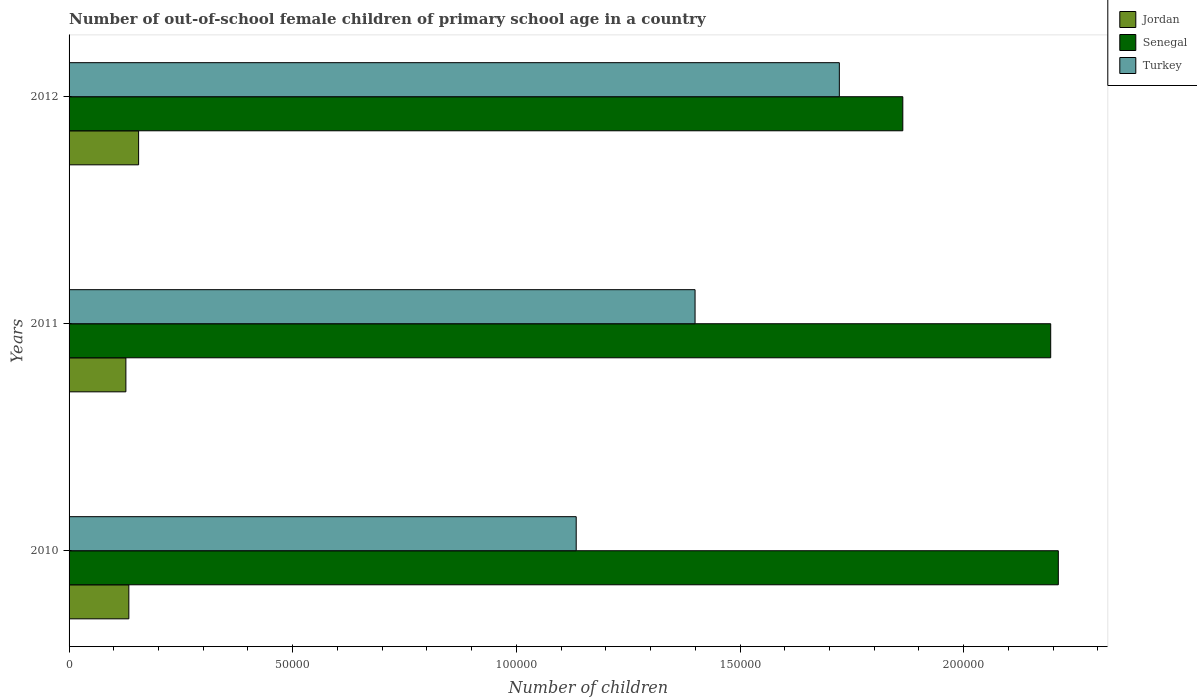How many different coloured bars are there?
Give a very brief answer. 3. Are the number of bars on each tick of the Y-axis equal?
Provide a short and direct response. Yes. How many bars are there on the 2nd tick from the top?
Your response must be concise. 3. How many bars are there on the 3rd tick from the bottom?
Ensure brevity in your answer.  3. What is the number of out-of-school female children in Jordan in 2010?
Keep it short and to the point. 1.34e+04. Across all years, what is the maximum number of out-of-school female children in Jordan?
Your response must be concise. 1.55e+04. Across all years, what is the minimum number of out-of-school female children in Jordan?
Give a very brief answer. 1.27e+04. In which year was the number of out-of-school female children in Turkey minimum?
Your response must be concise. 2010. What is the total number of out-of-school female children in Senegal in the graph?
Ensure brevity in your answer.  6.27e+05. What is the difference between the number of out-of-school female children in Senegal in 2010 and that in 2012?
Provide a short and direct response. 3.48e+04. What is the difference between the number of out-of-school female children in Senegal in 2010 and the number of out-of-school female children in Jordan in 2012?
Your answer should be compact. 2.06e+05. What is the average number of out-of-school female children in Turkey per year?
Make the answer very short. 1.42e+05. In the year 2012, what is the difference between the number of out-of-school female children in Senegal and number of out-of-school female children in Jordan?
Provide a short and direct response. 1.71e+05. In how many years, is the number of out-of-school female children in Jordan greater than 200000 ?
Provide a short and direct response. 0. What is the ratio of the number of out-of-school female children in Jordan in 2010 to that in 2012?
Ensure brevity in your answer.  0.86. Is the difference between the number of out-of-school female children in Senegal in 2010 and 2012 greater than the difference between the number of out-of-school female children in Jordan in 2010 and 2012?
Ensure brevity in your answer.  Yes. What is the difference between the highest and the second highest number of out-of-school female children in Senegal?
Provide a short and direct response. 1704. What is the difference between the highest and the lowest number of out-of-school female children in Senegal?
Give a very brief answer. 3.48e+04. Is the sum of the number of out-of-school female children in Jordan in 2011 and 2012 greater than the maximum number of out-of-school female children in Turkey across all years?
Your response must be concise. No. What does the 3rd bar from the top in 2010 represents?
Ensure brevity in your answer.  Jordan. What does the 3rd bar from the bottom in 2011 represents?
Your answer should be compact. Turkey. Is it the case that in every year, the sum of the number of out-of-school female children in Jordan and number of out-of-school female children in Senegal is greater than the number of out-of-school female children in Turkey?
Provide a succinct answer. Yes. How many bars are there?
Keep it short and to the point. 9. How many years are there in the graph?
Ensure brevity in your answer.  3. Are the values on the major ticks of X-axis written in scientific E-notation?
Your response must be concise. No. Where does the legend appear in the graph?
Keep it short and to the point. Top right. How many legend labels are there?
Your answer should be compact. 3. What is the title of the graph?
Provide a short and direct response. Number of out-of-school female children of primary school age in a country. What is the label or title of the X-axis?
Give a very brief answer. Number of children. What is the Number of children of Jordan in 2010?
Your answer should be very brief. 1.34e+04. What is the Number of children in Senegal in 2010?
Give a very brief answer. 2.21e+05. What is the Number of children in Turkey in 2010?
Your response must be concise. 1.13e+05. What is the Number of children in Jordan in 2011?
Offer a very short reply. 1.27e+04. What is the Number of children of Senegal in 2011?
Give a very brief answer. 2.19e+05. What is the Number of children of Turkey in 2011?
Provide a succinct answer. 1.40e+05. What is the Number of children in Jordan in 2012?
Offer a very short reply. 1.55e+04. What is the Number of children in Senegal in 2012?
Your answer should be very brief. 1.86e+05. What is the Number of children in Turkey in 2012?
Make the answer very short. 1.72e+05. Across all years, what is the maximum Number of children of Jordan?
Keep it short and to the point. 1.55e+04. Across all years, what is the maximum Number of children in Senegal?
Make the answer very short. 2.21e+05. Across all years, what is the maximum Number of children in Turkey?
Offer a very short reply. 1.72e+05. Across all years, what is the minimum Number of children in Jordan?
Offer a terse response. 1.27e+04. Across all years, what is the minimum Number of children in Senegal?
Ensure brevity in your answer.  1.86e+05. Across all years, what is the minimum Number of children in Turkey?
Your answer should be very brief. 1.13e+05. What is the total Number of children of Jordan in the graph?
Ensure brevity in your answer.  4.16e+04. What is the total Number of children of Senegal in the graph?
Your answer should be very brief. 6.27e+05. What is the total Number of children in Turkey in the graph?
Make the answer very short. 4.26e+05. What is the difference between the Number of children of Jordan in 2010 and that in 2011?
Your answer should be compact. 662. What is the difference between the Number of children of Senegal in 2010 and that in 2011?
Ensure brevity in your answer.  1704. What is the difference between the Number of children of Turkey in 2010 and that in 2011?
Your answer should be compact. -2.66e+04. What is the difference between the Number of children in Jordan in 2010 and that in 2012?
Provide a succinct answer. -2181. What is the difference between the Number of children of Senegal in 2010 and that in 2012?
Ensure brevity in your answer.  3.48e+04. What is the difference between the Number of children in Turkey in 2010 and that in 2012?
Ensure brevity in your answer.  -5.88e+04. What is the difference between the Number of children of Jordan in 2011 and that in 2012?
Keep it short and to the point. -2843. What is the difference between the Number of children of Senegal in 2011 and that in 2012?
Ensure brevity in your answer.  3.31e+04. What is the difference between the Number of children in Turkey in 2011 and that in 2012?
Your answer should be very brief. -3.23e+04. What is the difference between the Number of children in Jordan in 2010 and the Number of children in Senegal in 2011?
Ensure brevity in your answer.  -2.06e+05. What is the difference between the Number of children of Jordan in 2010 and the Number of children of Turkey in 2011?
Keep it short and to the point. -1.27e+05. What is the difference between the Number of children of Senegal in 2010 and the Number of children of Turkey in 2011?
Keep it short and to the point. 8.12e+04. What is the difference between the Number of children in Jordan in 2010 and the Number of children in Senegal in 2012?
Ensure brevity in your answer.  -1.73e+05. What is the difference between the Number of children of Jordan in 2010 and the Number of children of Turkey in 2012?
Make the answer very short. -1.59e+05. What is the difference between the Number of children in Senegal in 2010 and the Number of children in Turkey in 2012?
Give a very brief answer. 4.90e+04. What is the difference between the Number of children in Jordan in 2011 and the Number of children in Senegal in 2012?
Give a very brief answer. -1.74e+05. What is the difference between the Number of children of Jordan in 2011 and the Number of children of Turkey in 2012?
Ensure brevity in your answer.  -1.60e+05. What is the difference between the Number of children of Senegal in 2011 and the Number of children of Turkey in 2012?
Ensure brevity in your answer.  4.73e+04. What is the average Number of children of Jordan per year?
Provide a succinct answer. 1.39e+04. What is the average Number of children in Senegal per year?
Give a very brief answer. 2.09e+05. What is the average Number of children of Turkey per year?
Your answer should be very brief. 1.42e+05. In the year 2010, what is the difference between the Number of children of Jordan and Number of children of Senegal?
Provide a short and direct response. -2.08e+05. In the year 2010, what is the difference between the Number of children in Jordan and Number of children in Turkey?
Give a very brief answer. -1.00e+05. In the year 2010, what is the difference between the Number of children in Senegal and Number of children in Turkey?
Your answer should be compact. 1.08e+05. In the year 2011, what is the difference between the Number of children of Jordan and Number of children of Senegal?
Give a very brief answer. -2.07e+05. In the year 2011, what is the difference between the Number of children in Jordan and Number of children in Turkey?
Keep it short and to the point. -1.27e+05. In the year 2011, what is the difference between the Number of children of Senegal and Number of children of Turkey?
Your answer should be compact. 7.95e+04. In the year 2012, what is the difference between the Number of children in Jordan and Number of children in Senegal?
Offer a terse response. -1.71e+05. In the year 2012, what is the difference between the Number of children in Jordan and Number of children in Turkey?
Offer a terse response. -1.57e+05. In the year 2012, what is the difference between the Number of children of Senegal and Number of children of Turkey?
Give a very brief answer. 1.42e+04. What is the ratio of the Number of children in Jordan in 2010 to that in 2011?
Keep it short and to the point. 1.05. What is the ratio of the Number of children of Senegal in 2010 to that in 2011?
Offer a terse response. 1.01. What is the ratio of the Number of children of Turkey in 2010 to that in 2011?
Offer a terse response. 0.81. What is the ratio of the Number of children of Jordan in 2010 to that in 2012?
Offer a terse response. 0.86. What is the ratio of the Number of children in Senegal in 2010 to that in 2012?
Your answer should be very brief. 1.19. What is the ratio of the Number of children in Turkey in 2010 to that in 2012?
Your answer should be compact. 0.66. What is the ratio of the Number of children of Jordan in 2011 to that in 2012?
Your answer should be very brief. 0.82. What is the ratio of the Number of children of Senegal in 2011 to that in 2012?
Your answer should be compact. 1.18. What is the ratio of the Number of children of Turkey in 2011 to that in 2012?
Ensure brevity in your answer.  0.81. What is the difference between the highest and the second highest Number of children of Jordan?
Keep it short and to the point. 2181. What is the difference between the highest and the second highest Number of children in Senegal?
Make the answer very short. 1704. What is the difference between the highest and the second highest Number of children in Turkey?
Offer a very short reply. 3.23e+04. What is the difference between the highest and the lowest Number of children in Jordan?
Keep it short and to the point. 2843. What is the difference between the highest and the lowest Number of children of Senegal?
Your response must be concise. 3.48e+04. What is the difference between the highest and the lowest Number of children of Turkey?
Offer a very short reply. 5.88e+04. 